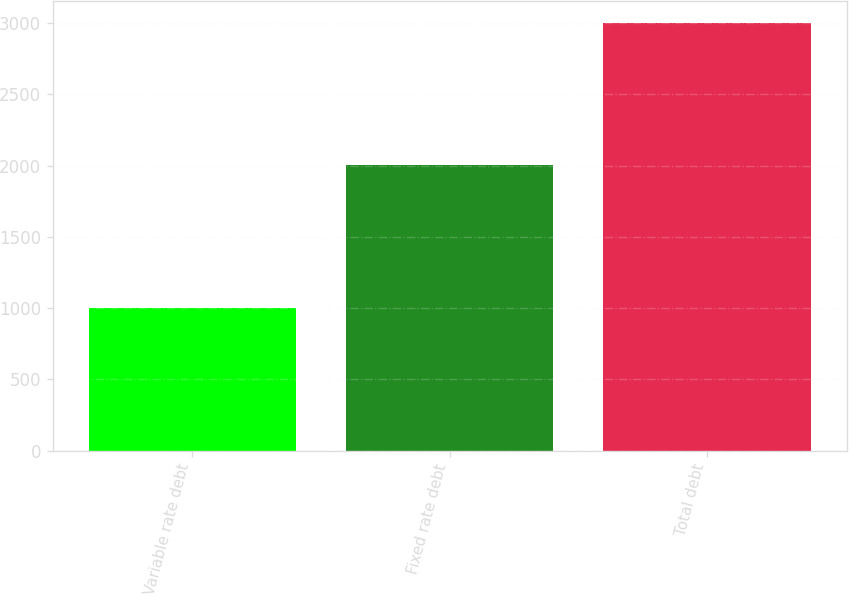Convert chart to OTSL. <chart><loc_0><loc_0><loc_500><loc_500><bar_chart><fcel>Variable rate debt<fcel>Fixed rate debt<fcel>Total debt<nl><fcel>997.4<fcel>2006.7<fcel>3004.1<nl></chart> 